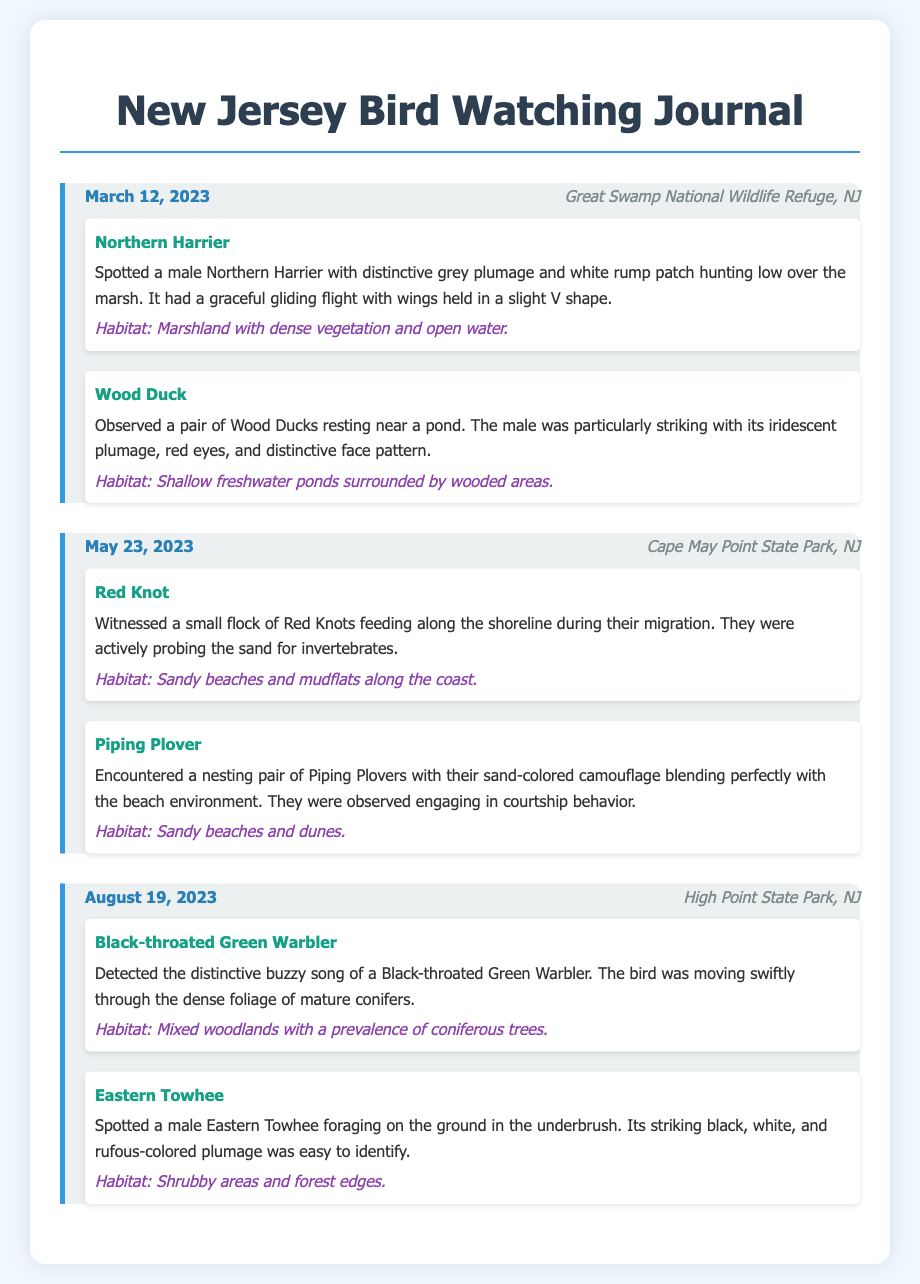What species was spotted on March 12, 2023? On March 12, 2023, the species observed were Northern Harrier and Wood Duck.
Answer: Northern Harrier, Wood Duck What habitat was the Wood Duck observed in? The Wood Duck was observed in shallow freshwater ponds surrounded by wooded areas.
Answer: Shallow freshwater ponds How many bird species were recorded in the entry for May 23, 2023? The entry for May 23, 2023, recorded two species: Red Knot and Piping Plover.
Answer: Two What is the location of the sightings on August 19, 2023? The sightings on August 19, 2023, occurred at High Point State Park, NJ.
Answer: High Point State Park, NJ Which bird is known for its distinctive buzzy song? The Black-throated Green Warbler is known for its distinctive buzzy song.
Answer: Black-throated Green Warbler In what type of habitat does the Eastern Towhee prefer? The Eastern Towhee prefers shrubby areas and forest edges.
Answer: Shrubby areas and forest edges What date was the Red Knot sighting? The Red Knot was sighted on May 23, 2023.
Answer: May 23, 2023 How did the male Northern Harrier’s plumage appear? The male Northern Harrier had distinctive grey plumage and a white rump patch.
Answer: Distinctive grey plumage and white rump patch 